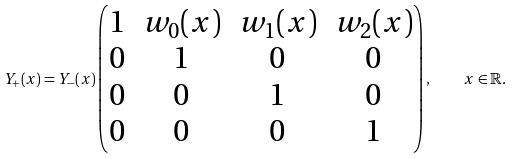<formula> <loc_0><loc_0><loc_500><loc_500>Y _ { + } ( x ) = Y _ { - } ( x ) \begin{pmatrix} 1 & w _ { 0 } ( x ) & w _ { 1 } ( x ) & w _ { 2 } ( x ) \\ 0 & 1 & 0 & 0 \\ 0 & 0 & 1 & 0 \\ 0 & 0 & 0 & 1 \end{pmatrix} , \quad x \in \mathbb { R } .</formula> 